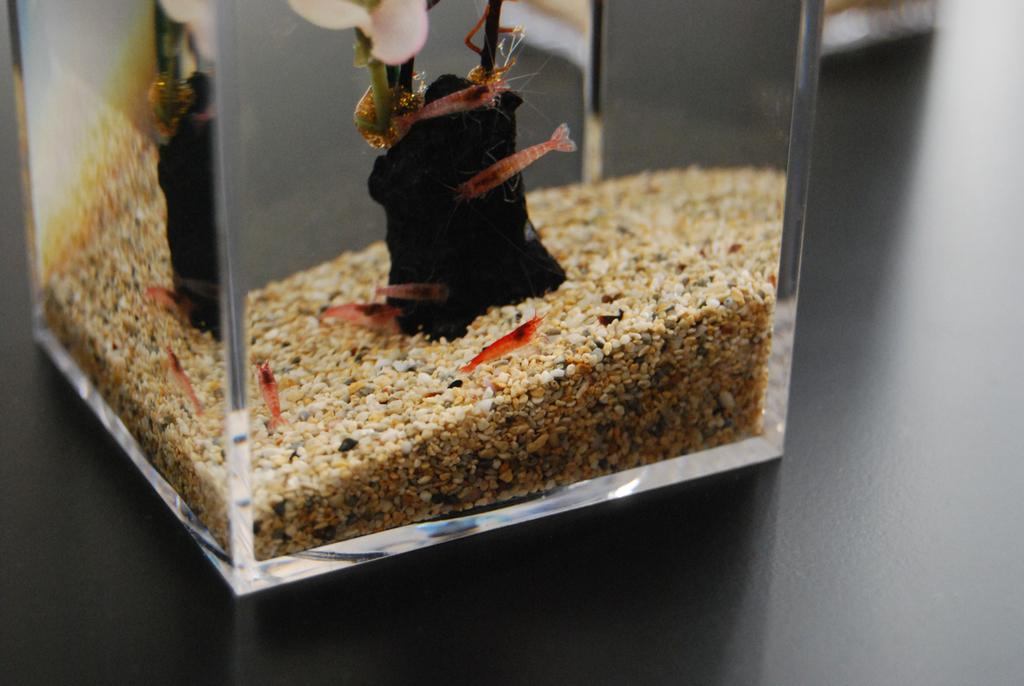What is the main subject of the picture? The main subject of the picture is an aquarium. What types of creatures can be seen in the aquarium? There are small fish in the aquarium. What else is present in the aquarium besides the fish? There are small pebbles in the aquarium. What type of pen is being used to write on the glass of the aquarium in the image? There is no pen or writing visible on the glass of the aquarium in the image. 